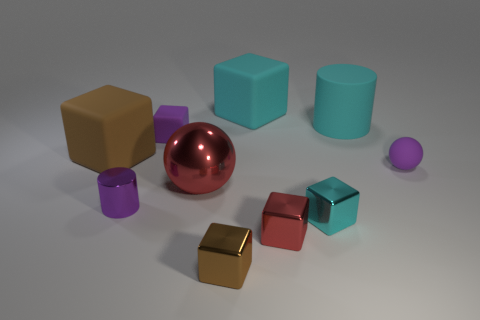There is a matte object that is the same color as the small sphere; what is its size?
Your answer should be very brief. Small. There is a tiny thing that is the same color as the big ball; what is its shape?
Keep it short and to the point. Cube. There is a tiny thing that is to the left of the large metal ball and in front of the red metal sphere; what is its shape?
Your answer should be compact. Cylinder. There is a tiny rubber ball; is it the same color as the cylinder on the left side of the small rubber block?
Keep it short and to the point. Yes. Is the size of the cyan thing in front of the red sphere the same as the small brown thing?
Make the answer very short. Yes. What material is the red object that is the same shape as the cyan metal thing?
Provide a succinct answer. Metal. Is the shape of the big brown object the same as the big metallic object?
Give a very brief answer. No. There is a red thing on the left side of the brown metallic block; how many tiny red cubes are behind it?
Ensure brevity in your answer.  0. What shape is the tiny purple thing that is made of the same material as the purple ball?
Your answer should be very brief. Cube. What number of purple objects are either tiny balls or cylinders?
Make the answer very short. 2. 